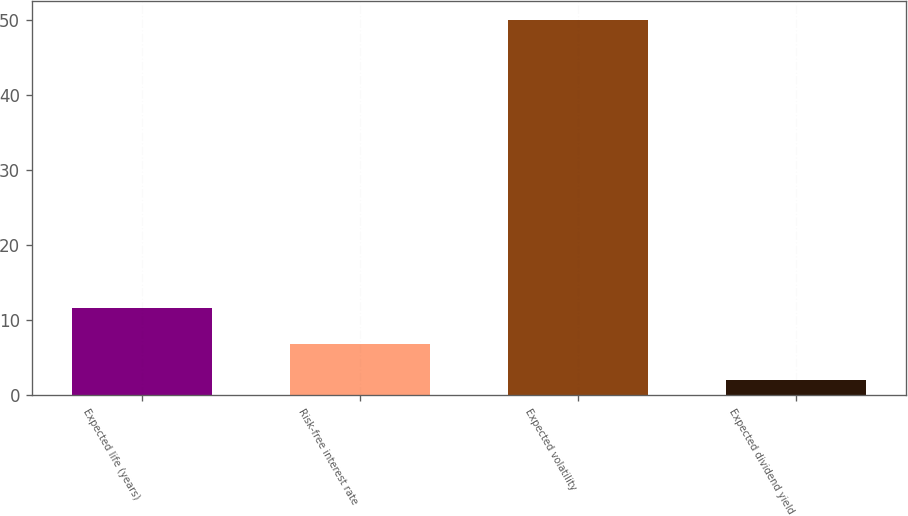<chart> <loc_0><loc_0><loc_500><loc_500><bar_chart><fcel>Expected life (years)<fcel>Risk-free interest rate<fcel>Expected volatility<fcel>Expected dividend yield<nl><fcel>11.6<fcel>6.8<fcel>50<fcel>2<nl></chart> 